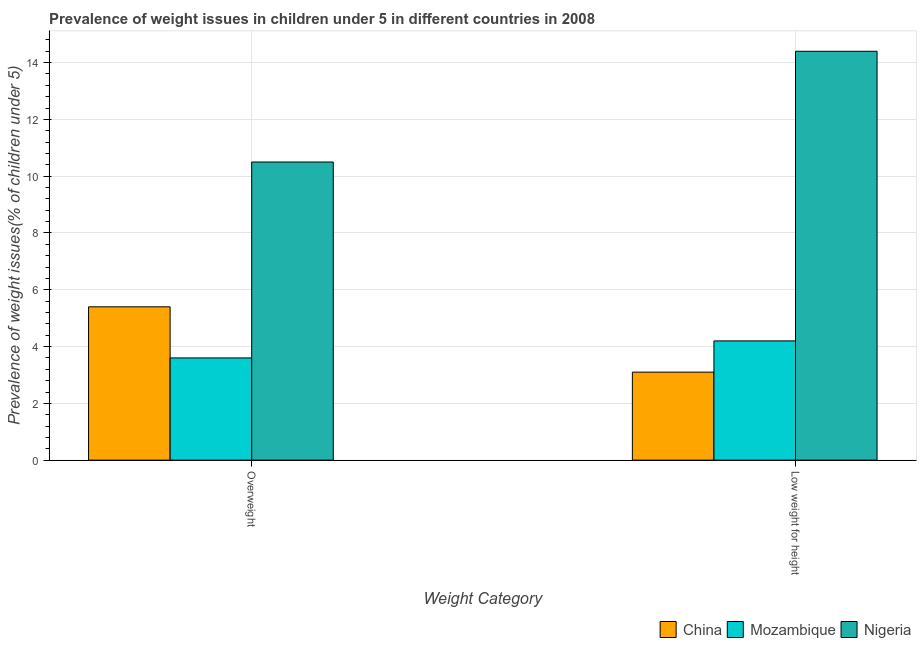How many different coloured bars are there?
Make the answer very short. 3. Are the number of bars on each tick of the X-axis equal?
Keep it short and to the point. Yes. How many bars are there on the 2nd tick from the left?
Your answer should be compact. 3. What is the label of the 1st group of bars from the left?
Your response must be concise. Overweight. What is the percentage of overweight children in Nigeria?
Your response must be concise. 10.5. Across all countries, what is the minimum percentage of underweight children?
Offer a very short reply. 3.1. In which country was the percentage of overweight children maximum?
Your answer should be compact. Nigeria. In which country was the percentage of overweight children minimum?
Your response must be concise. Mozambique. What is the difference between the percentage of overweight children in Nigeria and that in China?
Provide a succinct answer. 5.1. What is the difference between the percentage of overweight children in China and the percentage of underweight children in Nigeria?
Ensure brevity in your answer.  -9. What is the average percentage of underweight children per country?
Your answer should be compact. 7.23. What is the difference between the percentage of underweight children and percentage of overweight children in Nigeria?
Provide a short and direct response. 3.9. What is the ratio of the percentage of underweight children in Mozambique to that in Nigeria?
Your answer should be compact. 0.29. In how many countries, is the percentage of overweight children greater than the average percentage of overweight children taken over all countries?
Give a very brief answer. 1. What does the 2nd bar from the left in Overweight represents?
Offer a very short reply. Mozambique. How many bars are there?
Your answer should be compact. 6. Are all the bars in the graph horizontal?
Provide a short and direct response. No. How many countries are there in the graph?
Your answer should be compact. 3. What is the difference between two consecutive major ticks on the Y-axis?
Ensure brevity in your answer.  2. Are the values on the major ticks of Y-axis written in scientific E-notation?
Provide a short and direct response. No. Does the graph contain any zero values?
Provide a succinct answer. No. What is the title of the graph?
Offer a terse response. Prevalence of weight issues in children under 5 in different countries in 2008. What is the label or title of the X-axis?
Offer a very short reply. Weight Category. What is the label or title of the Y-axis?
Provide a succinct answer. Prevalence of weight issues(% of children under 5). What is the Prevalence of weight issues(% of children under 5) in China in Overweight?
Keep it short and to the point. 5.4. What is the Prevalence of weight issues(% of children under 5) in Mozambique in Overweight?
Your response must be concise. 3.6. What is the Prevalence of weight issues(% of children under 5) in China in Low weight for height?
Your response must be concise. 3.1. What is the Prevalence of weight issues(% of children under 5) of Mozambique in Low weight for height?
Provide a short and direct response. 4.2. What is the Prevalence of weight issues(% of children under 5) in Nigeria in Low weight for height?
Keep it short and to the point. 14.4. Across all Weight Category, what is the maximum Prevalence of weight issues(% of children under 5) of China?
Ensure brevity in your answer.  5.4. Across all Weight Category, what is the maximum Prevalence of weight issues(% of children under 5) of Mozambique?
Offer a very short reply. 4.2. Across all Weight Category, what is the maximum Prevalence of weight issues(% of children under 5) of Nigeria?
Your response must be concise. 14.4. Across all Weight Category, what is the minimum Prevalence of weight issues(% of children under 5) of China?
Provide a short and direct response. 3.1. Across all Weight Category, what is the minimum Prevalence of weight issues(% of children under 5) of Mozambique?
Make the answer very short. 3.6. What is the total Prevalence of weight issues(% of children under 5) in China in the graph?
Offer a terse response. 8.5. What is the total Prevalence of weight issues(% of children under 5) of Nigeria in the graph?
Offer a very short reply. 24.9. What is the difference between the Prevalence of weight issues(% of children under 5) of China in Overweight and that in Low weight for height?
Your answer should be very brief. 2.3. What is the difference between the Prevalence of weight issues(% of children under 5) of Nigeria in Overweight and that in Low weight for height?
Keep it short and to the point. -3.9. What is the difference between the Prevalence of weight issues(% of children under 5) in China in Overweight and the Prevalence of weight issues(% of children under 5) in Mozambique in Low weight for height?
Your answer should be very brief. 1.2. What is the difference between the Prevalence of weight issues(% of children under 5) of China in Overweight and the Prevalence of weight issues(% of children under 5) of Nigeria in Low weight for height?
Ensure brevity in your answer.  -9. What is the difference between the Prevalence of weight issues(% of children under 5) in Mozambique in Overweight and the Prevalence of weight issues(% of children under 5) in Nigeria in Low weight for height?
Keep it short and to the point. -10.8. What is the average Prevalence of weight issues(% of children under 5) in China per Weight Category?
Offer a terse response. 4.25. What is the average Prevalence of weight issues(% of children under 5) of Nigeria per Weight Category?
Ensure brevity in your answer.  12.45. What is the difference between the Prevalence of weight issues(% of children under 5) in Mozambique and Prevalence of weight issues(% of children under 5) in Nigeria in Overweight?
Offer a very short reply. -6.9. What is the difference between the Prevalence of weight issues(% of children under 5) in China and Prevalence of weight issues(% of children under 5) in Mozambique in Low weight for height?
Provide a short and direct response. -1.1. What is the difference between the Prevalence of weight issues(% of children under 5) of Mozambique and Prevalence of weight issues(% of children under 5) of Nigeria in Low weight for height?
Your answer should be compact. -10.2. What is the ratio of the Prevalence of weight issues(% of children under 5) of China in Overweight to that in Low weight for height?
Your answer should be very brief. 1.74. What is the ratio of the Prevalence of weight issues(% of children under 5) of Nigeria in Overweight to that in Low weight for height?
Make the answer very short. 0.73. What is the difference between the highest and the second highest Prevalence of weight issues(% of children under 5) in Nigeria?
Your response must be concise. 3.9. What is the difference between the highest and the lowest Prevalence of weight issues(% of children under 5) of China?
Your answer should be very brief. 2.3. What is the difference between the highest and the lowest Prevalence of weight issues(% of children under 5) of Mozambique?
Your answer should be very brief. 0.6. What is the difference between the highest and the lowest Prevalence of weight issues(% of children under 5) of Nigeria?
Ensure brevity in your answer.  3.9. 